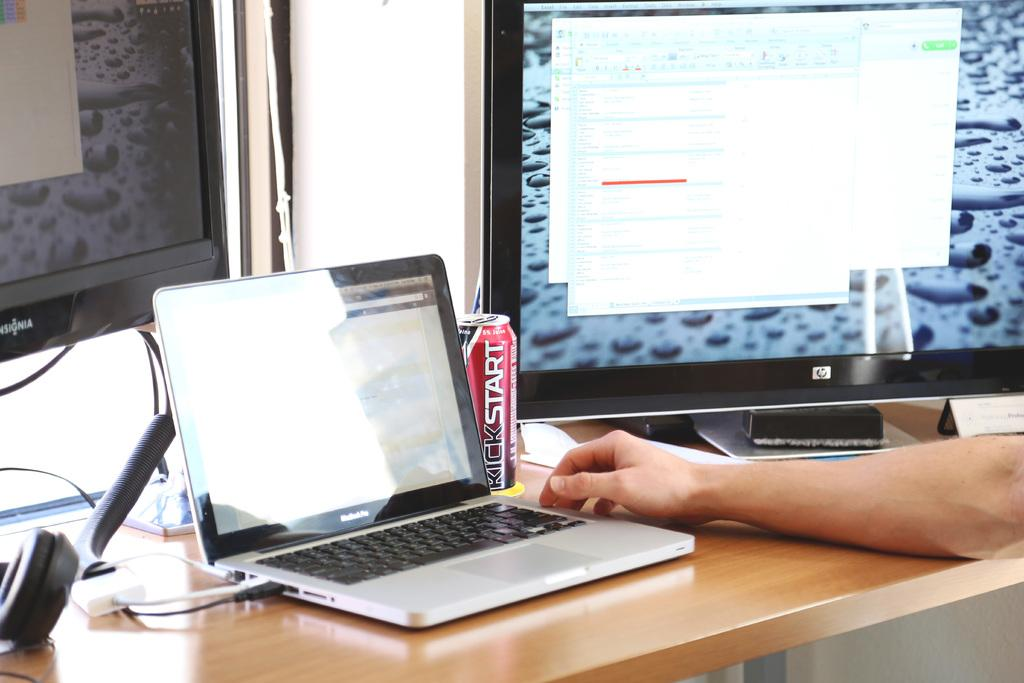What type of furniture is present in the image? There is a table in the image. What can be seen on the table? There is a hand of a person, a laptop, a tin, and a system on the table. What type of electronic device is on the table? There is a laptop on the table. What else is present on the table besides the laptop? There is a hand of a person, a tin, and a system on the table. What type of mitten is being used to operate the laptop in the image? There is no mitten present in the image, and the laptop is not being operated with a mitten. What type of oil is being used to lubricate the system in the image? There is no oil present in the image, and the system does not require lubrication. 